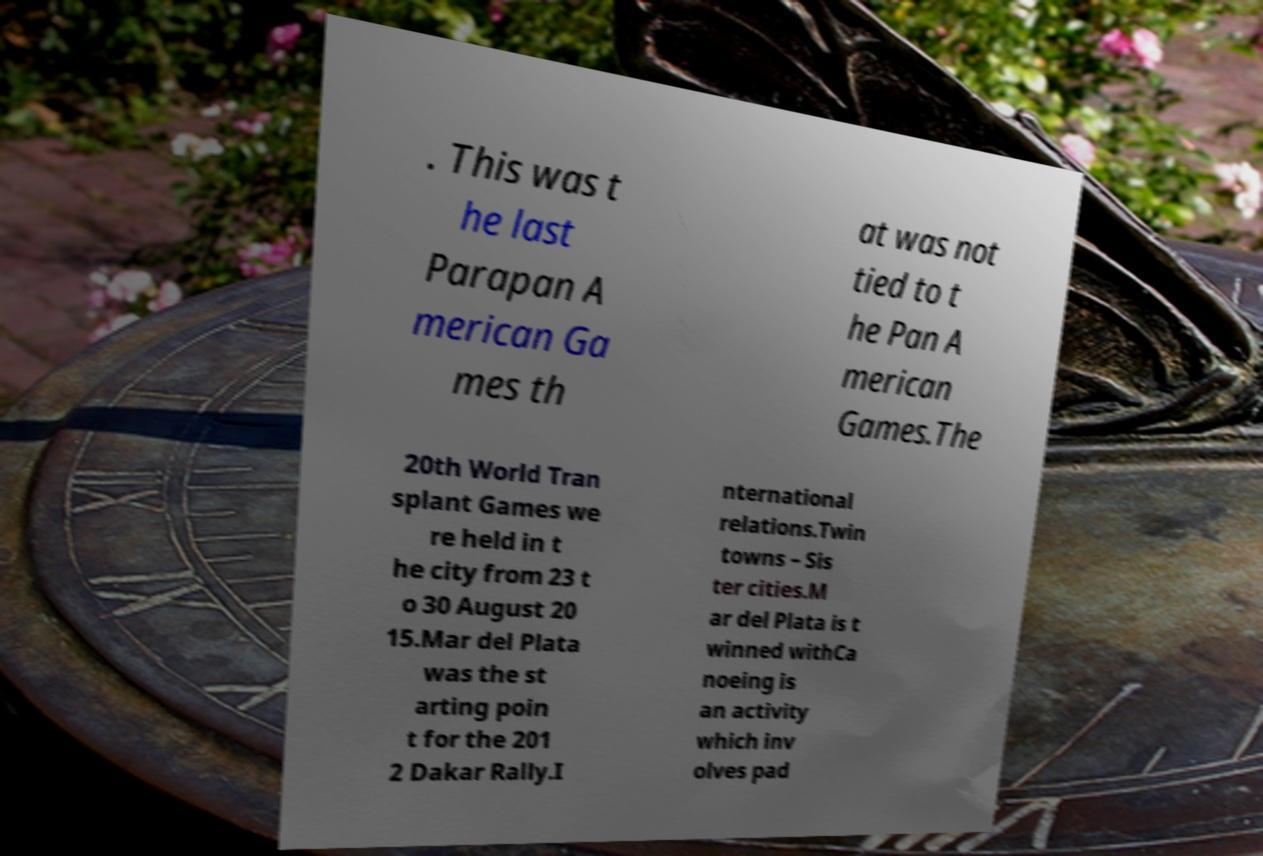Could you extract and type out the text from this image? . This was t he last Parapan A merican Ga mes th at was not tied to t he Pan A merican Games.The 20th World Tran splant Games we re held in t he city from 23 t o 30 August 20 15.Mar del Plata was the st arting poin t for the 201 2 Dakar Rally.I nternational relations.Twin towns – Sis ter cities.M ar del Plata is t winned withCa noeing is an activity which inv olves pad 